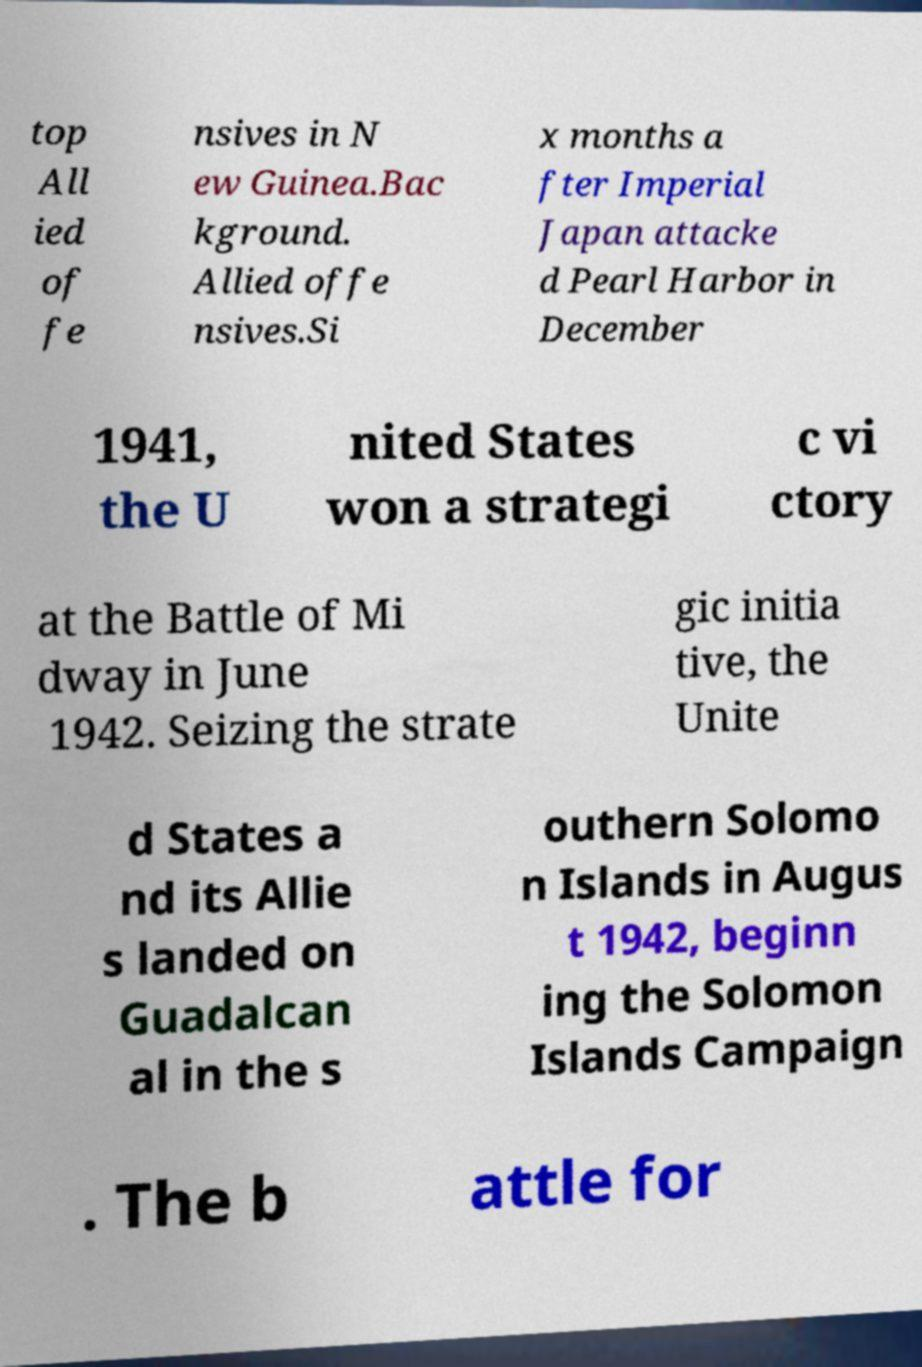Please read and relay the text visible in this image. What does it say? top All ied of fe nsives in N ew Guinea.Bac kground. Allied offe nsives.Si x months a fter Imperial Japan attacke d Pearl Harbor in December 1941, the U nited States won a strategi c vi ctory at the Battle of Mi dway in June 1942. Seizing the strate gic initia tive, the Unite d States a nd its Allie s landed on Guadalcan al in the s outhern Solomo n Islands in Augus t 1942, beginn ing the Solomon Islands Campaign . The b attle for 